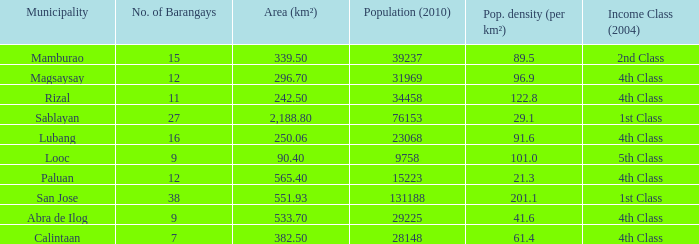List the population density per kilometer for the city of calintaan? 61.4. 